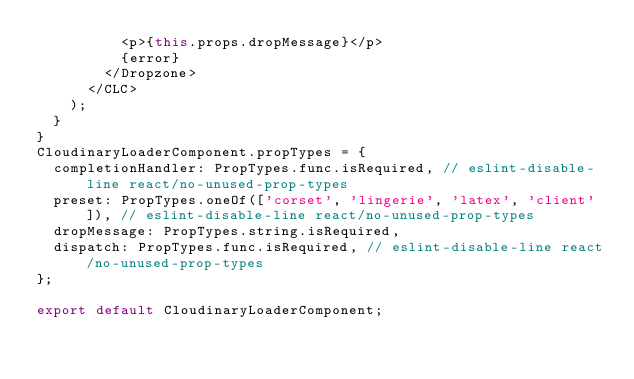<code> <loc_0><loc_0><loc_500><loc_500><_JavaScript_>          <p>{this.props.dropMessage}</p>
          {error}
        </Dropzone>
      </CLC>
    );
  }
}
CloudinaryLoaderComponent.propTypes = {
  completionHandler: PropTypes.func.isRequired, // eslint-disable-line react/no-unused-prop-types
  preset: PropTypes.oneOf(['corset', 'lingerie', 'latex', 'client']), // eslint-disable-line react/no-unused-prop-types
  dropMessage: PropTypes.string.isRequired,
  dispatch: PropTypes.func.isRequired, // eslint-disable-line react/no-unused-prop-types
};

export default CloudinaryLoaderComponent;
</code> 